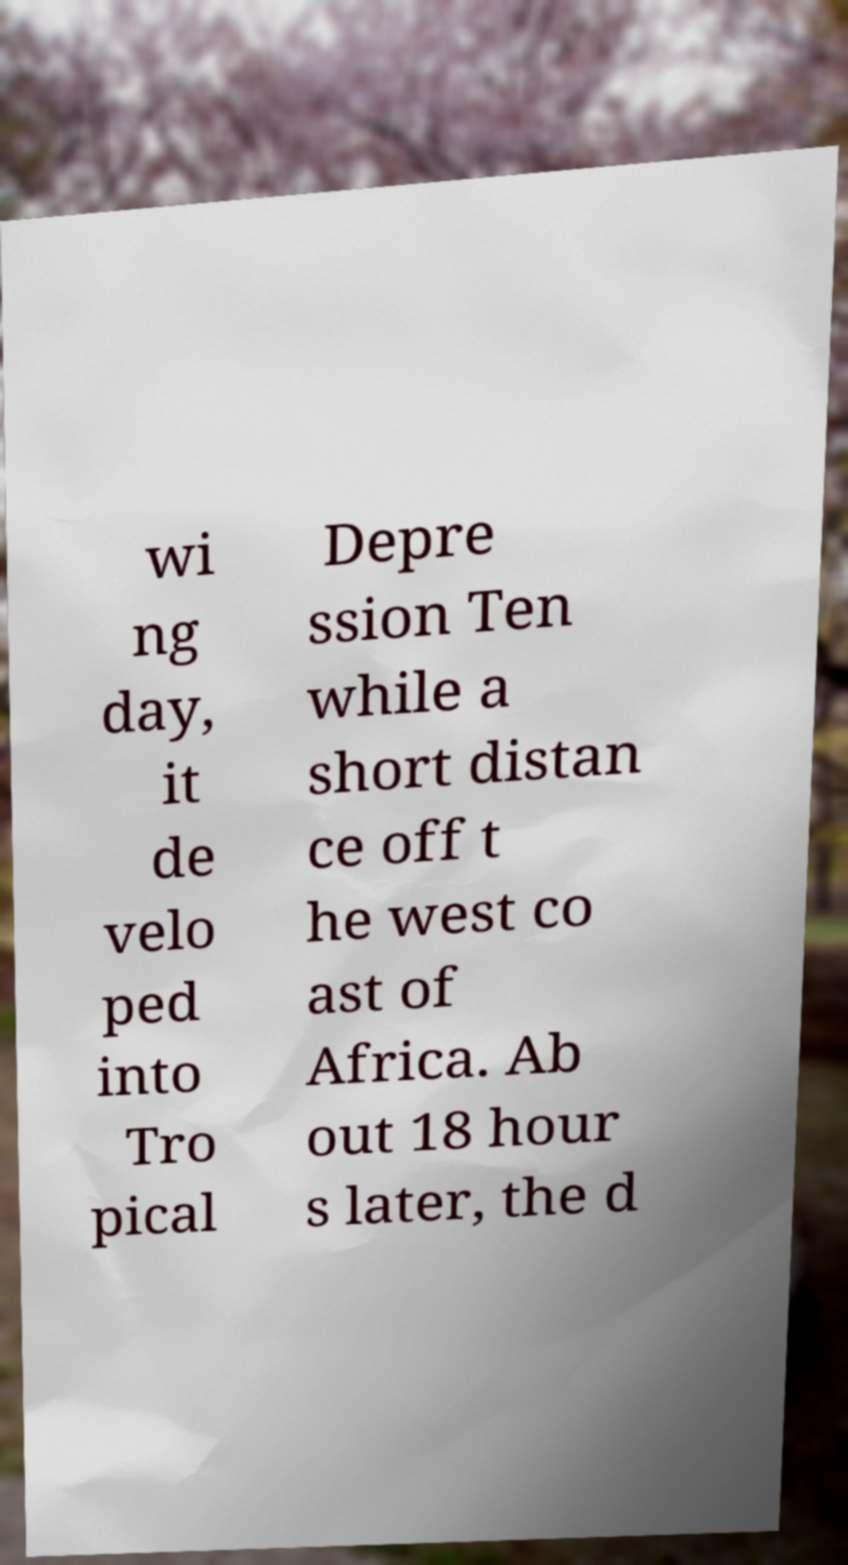What messages or text are displayed in this image? I need them in a readable, typed format. wi ng day, it de velo ped into Tro pical Depre ssion Ten while a short distan ce off t he west co ast of Africa. Ab out 18 hour s later, the d 